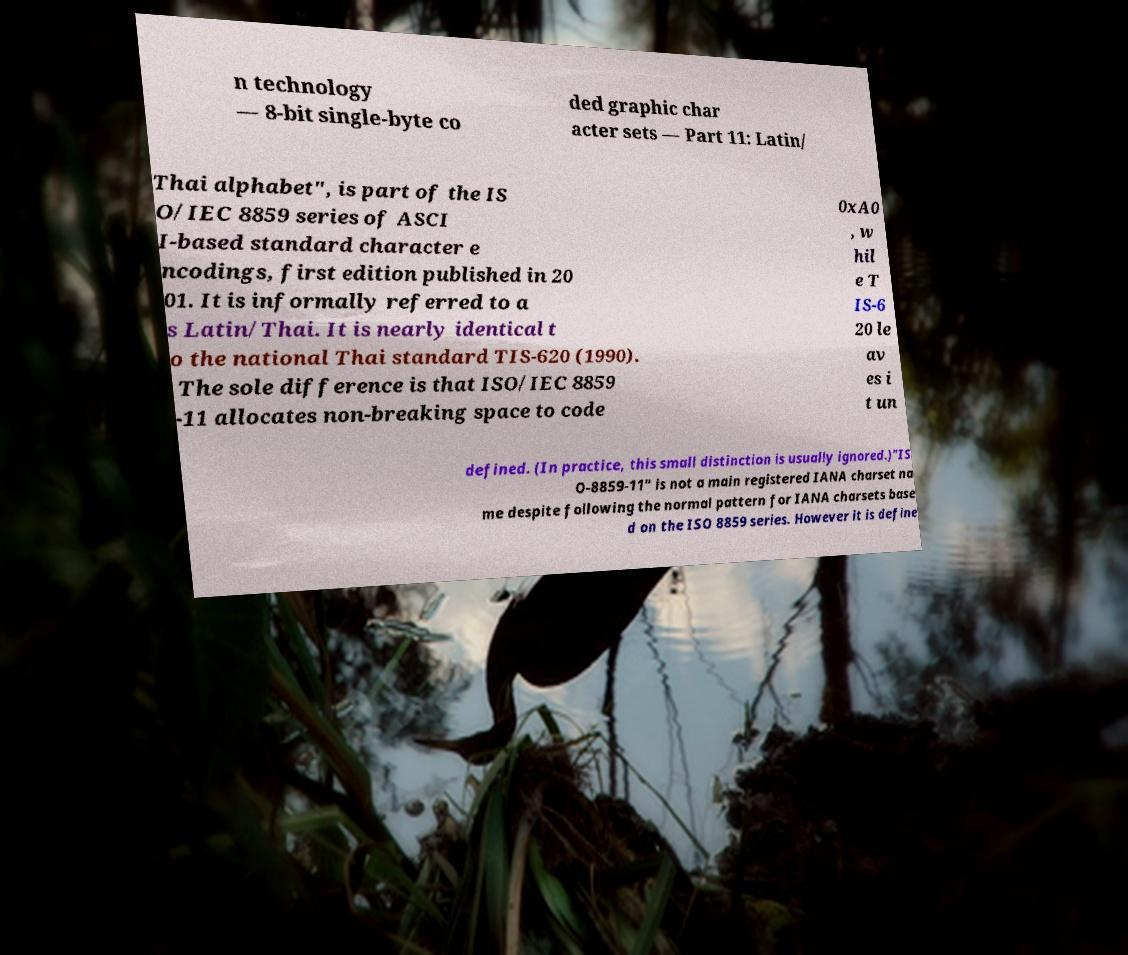Please read and relay the text visible in this image. What does it say? n technology — 8-bit single-byte co ded graphic char acter sets — Part 11: Latin/ Thai alphabet", is part of the IS O/IEC 8859 series of ASCI I-based standard character e ncodings, first edition published in 20 01. It is informally referred to a s Latin/Thai. It is nearly identical t o the national Thai standard TIS-620 (1990). The sole difference is that ISO/IEC 8859 -11 allocates non-breaking space to code 0xA0 , w hil e T IS-6 20 le av es i t un defined. (In practice, this small distinction is usually ignored.)"IS O-8859-11" is not a main registered IANA charset na me despite following the normal pattern for IANA charsets base d on the ISO 8859 series. However it is define 